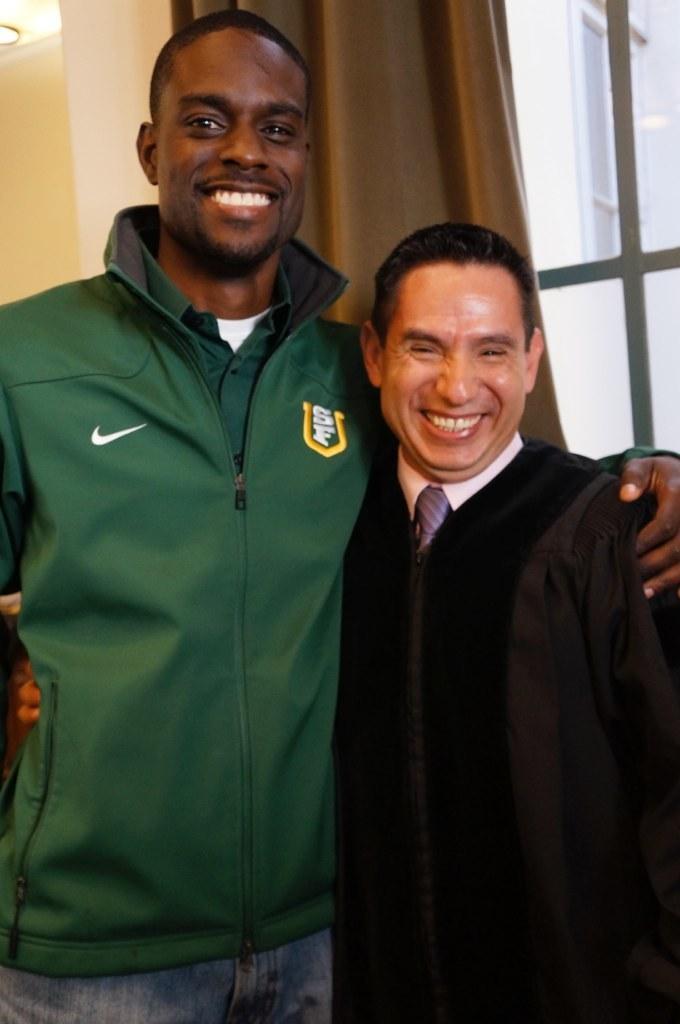Could you give a brief overview of what you see in this image? There are two persons standing as we can see in the middle of this image,and there is one curtain is present to a window in the background. 